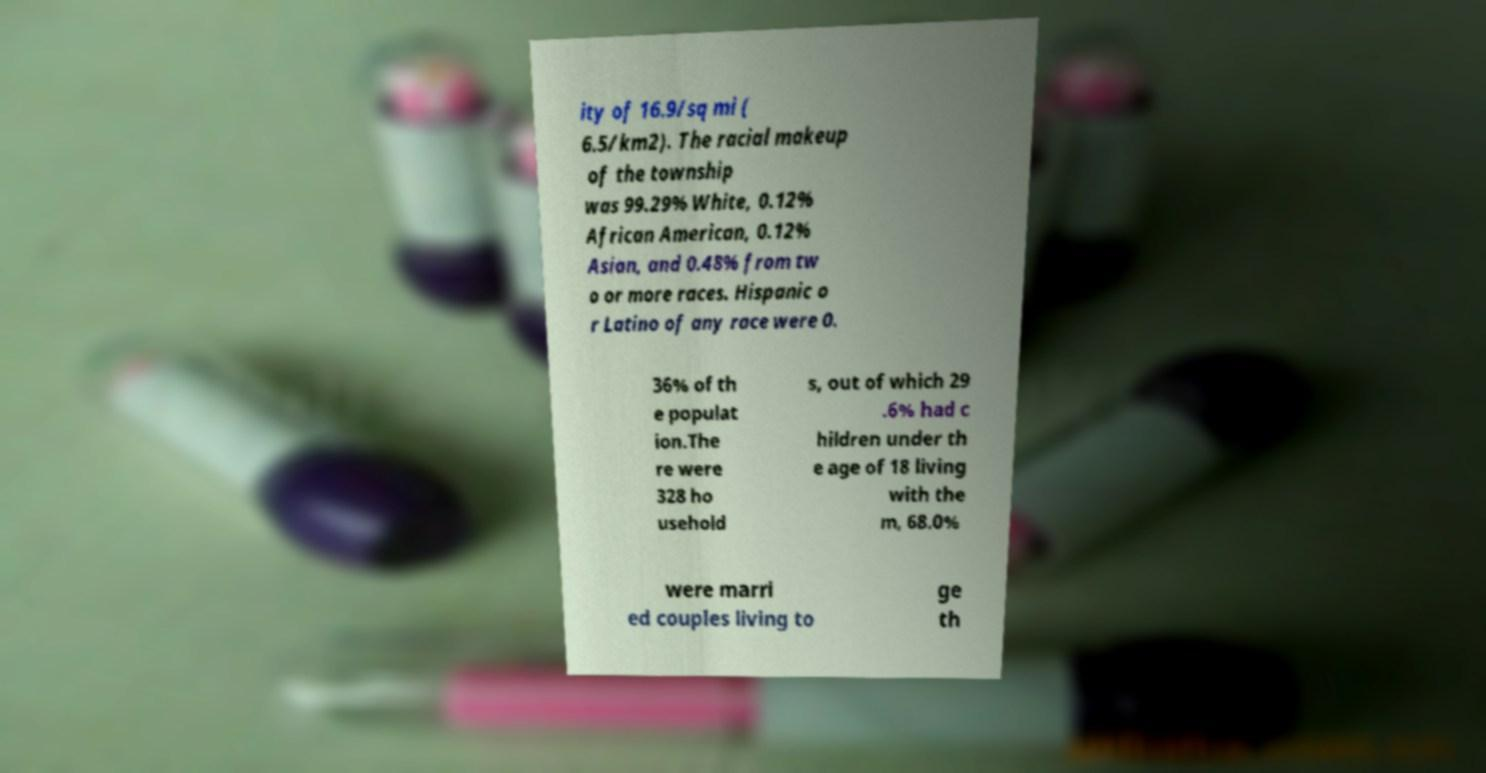Can you accurately transcribe the text from the provided image for me? ity of 16.9/sq mi ( 6.5/km2). The racial makeup of the township was 99.29% White, 0.12% African American, 0.12% Asian, and 0.48% from tw o or more races. Hispanic o r Latino of any race were 0. 36% of th e populat ion.The re were 328 ho usehold s, out of which 29 .6% had c hildren under th e age of 18 living with the m, 68.0% were marri ed couples living to ge th 